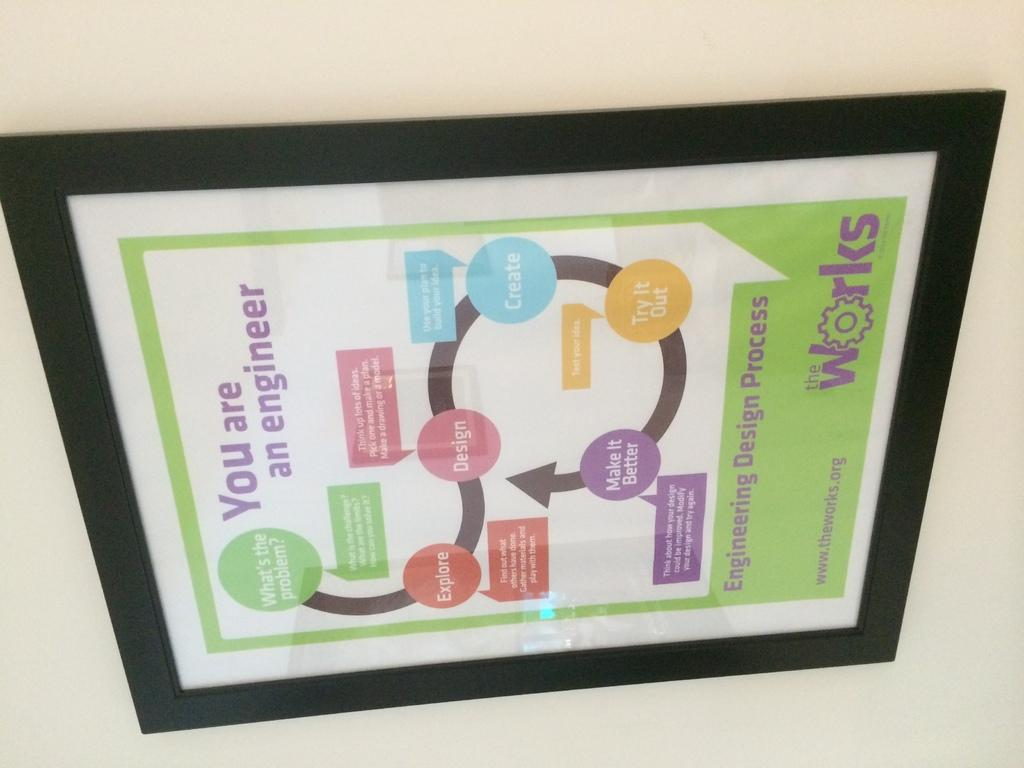<image>
Summarize the visual content of the image. A framed diagram on a wall from theworks.org called You Are An Engineer 